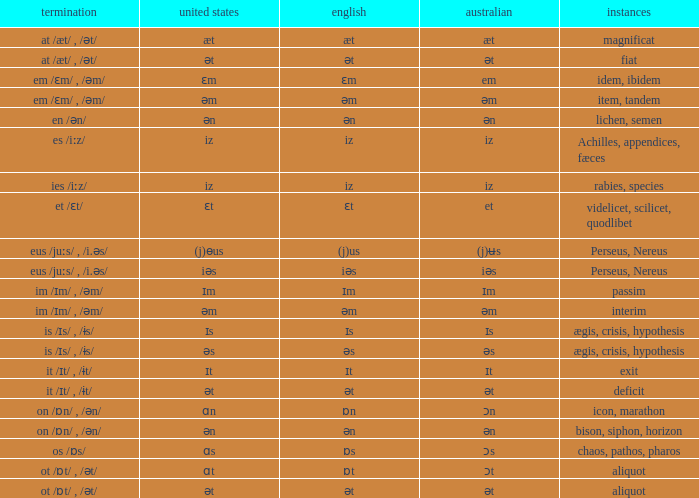Which Ending has British of iz, and Examples of achilles, appendices, fæces? Es /iːz/. Could you parse the entire table as a dict? {'header': ['termination', 'united states', 'english', 'australian', 'instances'], 'rows': [['at /æt/ , /ət/', 'æt', 'æt', 'æt', 'magnificat'], ['at /æt/ , /ət/', 'ət', 'ət', 'ət', 'fiat'], ['em /ɛm/ , /əm/', 'ɛm', 'ɛm', 'em', 'idem, ibidem'], ['em /ɛm/ , /əm/', 'əm', 'əm', 'əm', 'item, tandem'], ['en /ən/', 'ən', 'ən', 'ən', 'lichen, semen'], ['es /iːz/', 'iz', 'iz', 'iz', 'Achilles, appendices, fæces'], ['ies /iːz/', 'iz', 'iz', 'iz', 'rabies, species'], ['et /ɛt/', 'ɛt', 'ɛt', 'et', 'videlicet, scilicet, quodlibet'], ['eus /juːs/ , /i.əs/', '(j)ɵus', '(j)us', '(j)ʉs', 'Perseus, Nereus'], ['eus /juːs/ , /i.əs/', 'iəs', 'iəs', 'iəs', 'Perseus, Nereus'], ['im /ɪm/ , /əm/', 'ɪm', 'ɪm', 'ɪm', 'passim'], ['im /ɪm/ , /əm/', 'əm', 'əm', 'əm', 'interim'], ['is /ɪs/ , /ɨs/', 'ɪs', 'ɪs', 'ɪs', 'ægis, crisis, hypothesis'], ['is /ɪs/ , /ɨs/', 'əs', 'əs', 'əs', 'ægis, crisis, hypothesis'], ['it /ɪt/ , /ɨt/', 'ɪt', 'ɪt', 'ɪt', 'exit'], ['it /ɪt/ , /ɨt/', 'ət', 'ət', 'ət', 'deficit'], ['on /ɒn/ , /ən/', 'ɑn', 'ɒn', 'ɔn', 'icon, marathon'], ['on /ɒn/ , /ən/', 'ən', 'ən', 'ən', 'bison, siphon, horizon'], ['os /ɒs/', 'ɑs', 'ɒs', 'ɔs', 'chaos, pathos, pharos'], ['ot /ɒt/ , /ət/', 'ɑt', 'ɒt', 'ɔt', 'aliquot'], ['ot /ɒt/ , /ət/', 'ət', 'ət', 'ət', 'aliquot']]} 